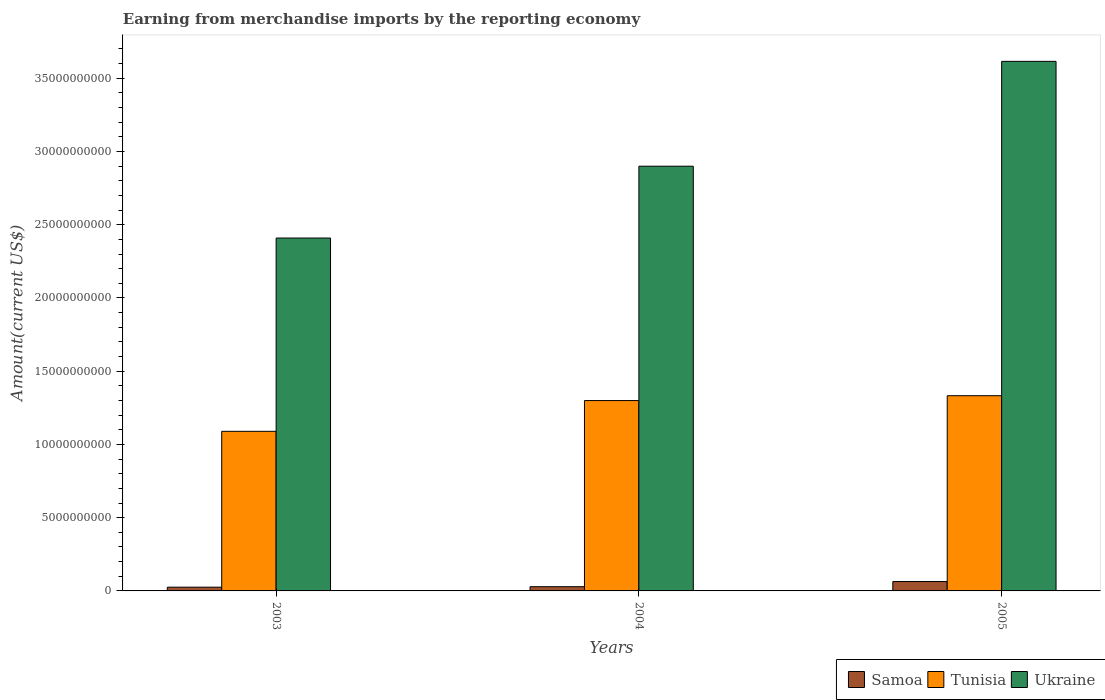How many groups of bars are there?
Give a very brief answer. 3. What is the label of the 3rd group of bars from the left?
Keep it short and to the point. 2005. What is the amount earned from merchandise imports in Samoa in 2003?
Offer a very short reply. 2.55e+08. Across all years, what is the maximum amount earned from merchandise imports in Ukraine?
Provide a succinct answer. 3.62e+1. Across all years, what is the minimum amount earned from merchandise imports in Samoa?
Give a very brief answer. 2.55e+08. In which year was the amount earned from merchandise imports in Tunisia maximum?
Your response must be concise. 2005. In which year was the amount earned from merchandise imports in Tunisia minimum?
Your answer should be very brief. 2003. What is the total amount earned from merchandise imports in Tunisia in the graph?
Make the answer very short. 3.72e+1. What is the difference between the amount earned from merchandise imports in Ukraine in 2003 and that in 2004?
Your response must be concise. -4.90e+09. What is the difference between the amount earned from merchandise imports in Ukraine in 2003 and the amount earned from merchandise imports in Samoa in 2005?
Keep it short and to the point. 2.35e+1. What is the average amount earned from merchandise imports in Tunisia per year?
Keep it short and to the point. 1.24e+1. In the year 2005, what is the difference between the amount earned from merchandise imports in Samoa and amount earned from merchandise imports in Tunisia?
Your answer should be compact. -1.27e+1. What is the ratio of the amount earned from merchandise imports in Samoa in 2003 to that in 2005?
Offer a very short reply. 0.4. Is the amount earned from merchandise imports in Samoa in 2003 less than that in 2004?
Ensure brevity in your answer.  Yes. Is the difference between the amount earned from merchandise imports in Samoa in 2003 and 2004 greater than the difference between the amount earned from merchandise imports in Tunisia in 2003 and 2004?
Make the answer very short. Yes. What is the difference between the highest and the second highest amount earned from merchandise imports in Ukraine?
Provide a short and direct response. 7.16e+09. What is the difference between the highest and the lowest amount earned from merchandise imports in Tunisia?
Provide a succinct answer. 2.43e+09. In how many years, is the amount earned from merchandise imports in Ukraine greater than the average amount earned from merchandise imports in Ukraine taken over all years?
Keep it short and to the point. 1. What does the 2nd bar from the left in 2003 represents?
Offer a terse response. Tunisia. What does the 1st bar from the right in 2003 represents?
Keep it short and to the point. Ukraine. What is the difference between two consecutive major ticks on the Y-axis?
Offer a terse response. 5.00e+09. Does the graph contain any zero values?
Make the answer very short. No. Does the graph contain grids?
Provide a short and direct response. No. How are the legend labels stacked?
Keep it short and to the point. Horizontal. What is the title of the graph?
Your response must be concise. Earning from merchandise imports by the reporting economy. What is the label or title of the X-axis?
Offer a very short reply. Years. What is the label or title of the Y-axis?
Provide a succinct answer. Amount(current US$). What is the Amount(current US$) of Samoa in 2003?
Make the answer very short. 2.55e+08. What is the Amount(current US$) of Tunisia in 2003?
Offer a terse response. 1.09e+1. What is the Amount(current US$) of Ukraine in 2003?
Give a very brief answer. 2.41e+1. What is the Amount(current US$) of Samoa in 2004?
Provide a short and direct response. 2.89e+08. What is the Amount(current US$) in Tunisia in 2004?
Give a very brief answer. 1.30e+1. What is the Amount(current US$) of Ukraine in 2004?
Your answer should be compact. 2.90e+1. What is the Amount(current US$) in Samoa in 2005?
Provide a succinct answer. 6.41e+08. What is the Amount(current US$) of Tunisia in 2005?
Provide a short and direct response. 1.33e+1. What is the Amount(current US$) in Ukraine in 2005?
Give a very brief answer. 3.62e+1. Across all years, what is the maximum Amount(current US$) of Samoa?
Offer a terse response. 6.41e+08. Across all years, what is the maximum Amount(current US$) of Tunisia?
Your answer should be very brief. 1.33e+1. Across all years, what is the maximum Amount(current US$) in Ukraine?
Offer a terse response. 3.62e+1. Across all years, what is the minimum Amount(current US$) of Samoa?
Keep it short and to the point. 2.55e+08. Across all years, what is the minimum Amount(current US$) in Tunisia?
Keep it short and to the point. 1.09e+1. Across all years, what is the minimum Amount(current US$) of Ukraine?
Your response must be concise. 2.41e+1. What is the total Amount(current US$) in Samoa in the graph?
Offer a terse response. 1.18e+09. What is the total Amount(current US$) in Tunisia in the graph?
Keep it short and to the point. 3.72e+1. What is the total Amount(current US$) in Ukraine in the graph?
Offer a very short reply. 8.92e+1. What is the difference between the Amount(current US$) of Samoa in 2003 and that in 2004?
Give a very brief answer. -3.36e+07. What is the difference between the Amount(current US$) in Tunisia in 2003 and that in 2004?
Give a very brief answer. -2.10e+09. What is the difference between the Amount(current US$) of Ukraine in 2003 and that in 2004?
Ensure brevity in your answer.  -4.90e+09. What is the difference between the Amount(current US$) of Samoa in 2003 and that in 2005?
Provide a short and direct response. -3.86e+08. What is the difference between the Amount(current US$) in Tunisia in 2003 and that in 2005?
Provide a short and direct response. -2.43e+09. What is the difference between the Amount(current US$) of Ukraine in 2003 and that in 2005?
Provide a short and direct response. -1.21e+1. What is the difference between the Amount(current US$) in Samoa in 2004 and that in 2005?
Your answer should be very brief. -3.52e+08. What is the difference between the Amount(current US$) in Tunisia in 2004 and that in 2005?
Provide a short and direct response. -3.32e+08. What is the difference between the Amount(current US$) of Ukraine in 2004 and that in 2005?
Provide a short and direct response. -7.16e+09. What is the difference between the Amount(current US$) in Samoa in 2003 and the Amount(current US$) in Tunisia in 2004?
Ensure brevity in your answer.  -1.27e+1. What is the difference between the Amount(current US$) in Samoa in 2003 and the Amount(current US$) in Ukraine in 2004?
Give a very brief answer. -2.87e+1. What is the difference between the Amount(current US$) in Tunisia in 2003 and the Amount(current US$) in Ukraine in 2004?
Provide a succinct answer. -1.81e+1. What is the difference between the Amount(current US$) of Samoa in 2003 and the Amount(current US$) of Tunisia in 2005?
Offer a very short reply. -1.31e+1. What is the difference between the Amount(current US$) in Samoa in 2003 and the Amount(current US$) in Ukraine in 2005?
Offer a terse response. -3.59e+1. What is the difference between the Amount(current US$) in Tunisia in 2003 and the Amount(current US$) in Ukraine in 2005?
Provide a succinct answer. -2.53e+1. What is the difference between the Amount(current US$) in Samoa in 2004 and the Amount(current US$) in Tunisia in 2005?
Offer a terse response. -1.30e+1. What is the difference between the Amount(current US$) in Samoa in 2004 and the Amount(current US$) in Ukraine in 2005?
Make the answer very short. -3.59e+1. What is the difference between the Amount(current US$) of Tunisia in 2004 and the Amount(current US$) of Ukraine in 2005?
Keep it short and to the point. -2.32e+1. What is the average Amount(current US$) in Samoa per year?
Provide a succinct answer. 3.95e+08. What is the average Amount(current US$) of Tunisia per year?
Offer a very short reply. 1.24e+1. What is the average Amount(current US$) in Ukraine per year?
Offer a terse response. 2.97e+1. In the year 2003, what is the difference between the Amount(current US$) in Samoa and Amount(current US$) in Tunisia?
Keep it short and to the point. -1.06e+1. In the year 2003, what is the difference between the Amount(current US$) in Samoa and Amount(current US$) in Ukraine?
Your answer should be very brief. -2.38e+1. In the year 2003, what is the difference between the Amount(current US$) in Tunisia and Amount(current US$) in Ukraine?
Give a very brief answer. -1.32e+1. In the year 2004, what is the difference between the Amount(current US$) in Samoa and Amount(current US$) in Tunisia?
Provide a short and direct response. -1.27e+1. In the year 2004, what is the difference between the Amount(current US$) of Samoa and Amount(current US$) of Ukraine?
Provide a short and direct response. -2.87e+1. In the year 2004, what is the difference between the Amount(current US$) of Tunisia and Amount(current US$) of Ukraine?
Offer a very short reply. -1.60e+1. In the year 2005, what is the difference between the Amount(current US$) of Samoa and Amount(current US$) of Tunisia?
Offer a very short reply. -1.27e+1. In the year 2005, what is the difference between the Amount(current US$) in Samoa and Amount(current US$) in Ukraine?
Keep it short and to the point. -3.55e+1. In the year 2005, what is the difference between the Amount(current US$) in Tunisia and Amount(current US$) in Ukraine?
Your answer should be compact. -2.28e+1. What is the ratio of the Amount(current US$) in Samoa in 2003 to that in 2004?
Your answer should be compact. 0.88. What is the ratio of the Amount(current US$) in Tunisia in 2003 to that in 2004?
Make the answer very short. 0.84. What is the ratio of the Amount(current US$) in Ukraine in 2003 to that in 2004?
Keep it short and to the point. 0.83. What is the ratio of the Amount(current US$) in Samoa in 2003 to that in 2005?
Give a very brief answer. 0.4. What is the ratio of the Amount(current US$) in Tunisia in 2003 to that in 2005?
Your answer should be very brief. 0.82. What is the ratio of the Amount(current US$) of Ukraine in 2003 to that in 2005?
Offer a very short reply. 0.67. What is the ratio of the Amount(current US$) of Samoa in 2004 to that in 2005?
Give a very brief answer. 0.45. What is the ratio of the Amount(current US$) in Tunisia in 2004 to that in 2005?
Your answer should be very brief. 0.98. What is the ratio of the Amount(current US$) of Ukraine in 2004 to that in 2005?
Offer a terse response. 0.8. What is the difference between the highest and the second highest Amount(current US$) of Samoa?
Keep it short and to the point. 3.52e+08. What is the difference between the highest and the second highest Amount(current US$) of Tunisia?
Your response must be concise. 3.32e+08. What is the difference between the highest and the second highest Amount(current US$) of Ukraine?
Make the answer very short. 7.16e+09. What is the difference between the highest and the lowest Amount(current US$) of Samoa?
Offer a terse response. 3.86e+08. What is the difference between the highest and the lowest Amount(current US$) of Tunisia?
Keep it short and to the point. 2.43e+09. What is the difference between the highest and the lowest Amount(current US$) of Ukraine?
Your response must be concise. 1.21e+1. 